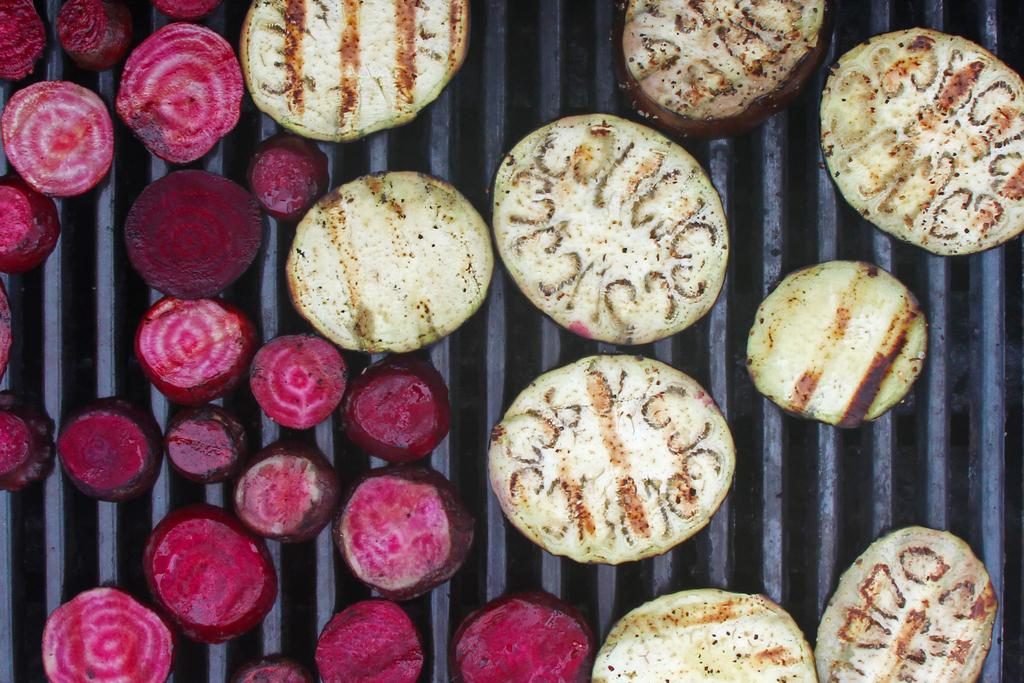What type of food can be seen in the image? There are beetroot pieces in the image. Are there any other food items visible besides the beetroot? Yes, there are other food items in the image. How are the food items arranged or displayed in the image? The food items are placed on a metal frame. What type of bomb is hidden among the food items in the image? There is no bomb present in the image; it only contains food items arranged on a metal frame. 